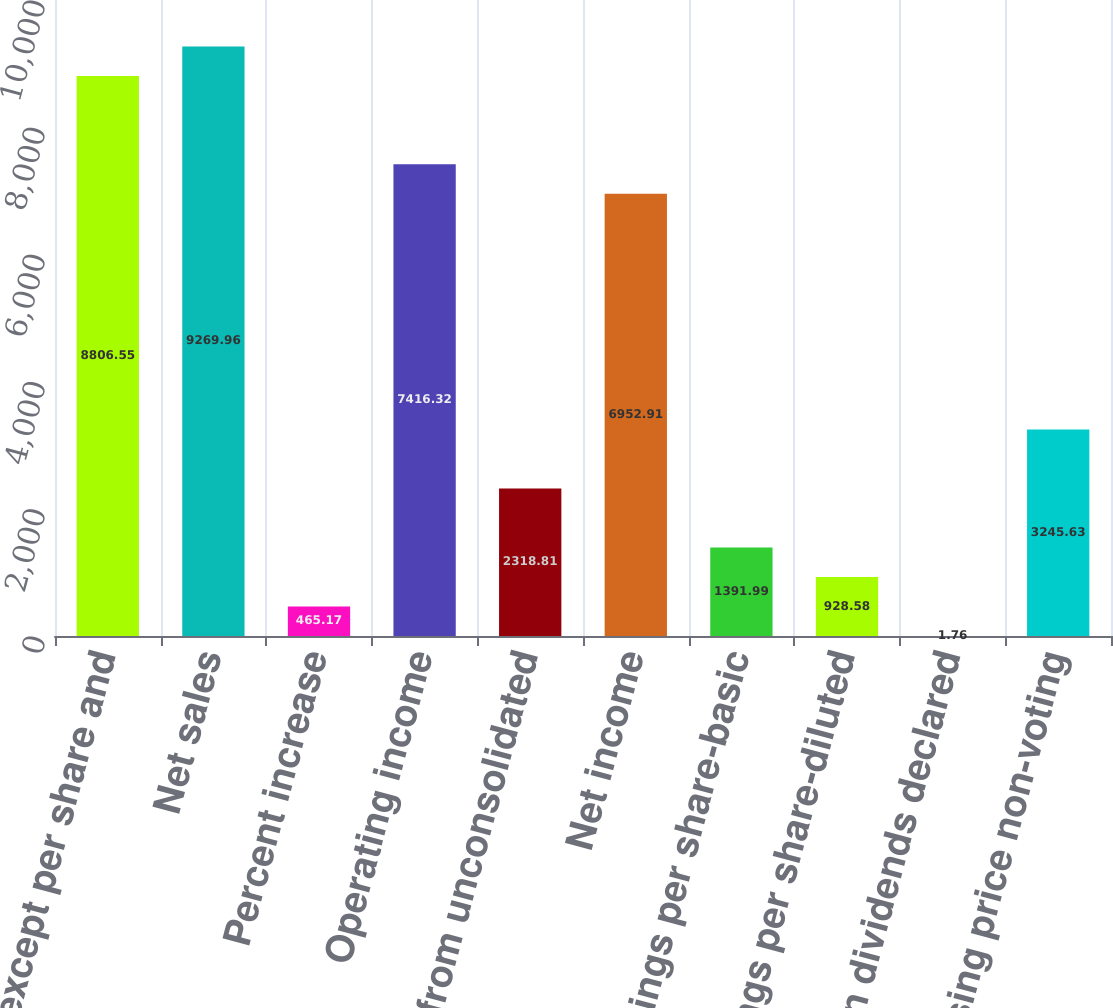Convert chart. <chart><loc_0><loc_0><loc_500><loc_500><bar_chart><fcel>(millions except per share and<fcel>Net sales<fcel>Percent increase<fcel>Operating income<fcel>Income from unconsolidated<fcel>Net income<fcel>Earnings per share-basic<fcel>Earnings per share-diluted<fcel>Common dividends declared<fcel>Closing price non-voting<nl><fcel>8806.55<fcel>9269.96<fcel>465.17<fcel>7416.32<fcel>2318.81<fcel>6952.91<fcel>1391.99<fcel>928.58<fcel>1.76<fcel>3245.63<nl></chart> 